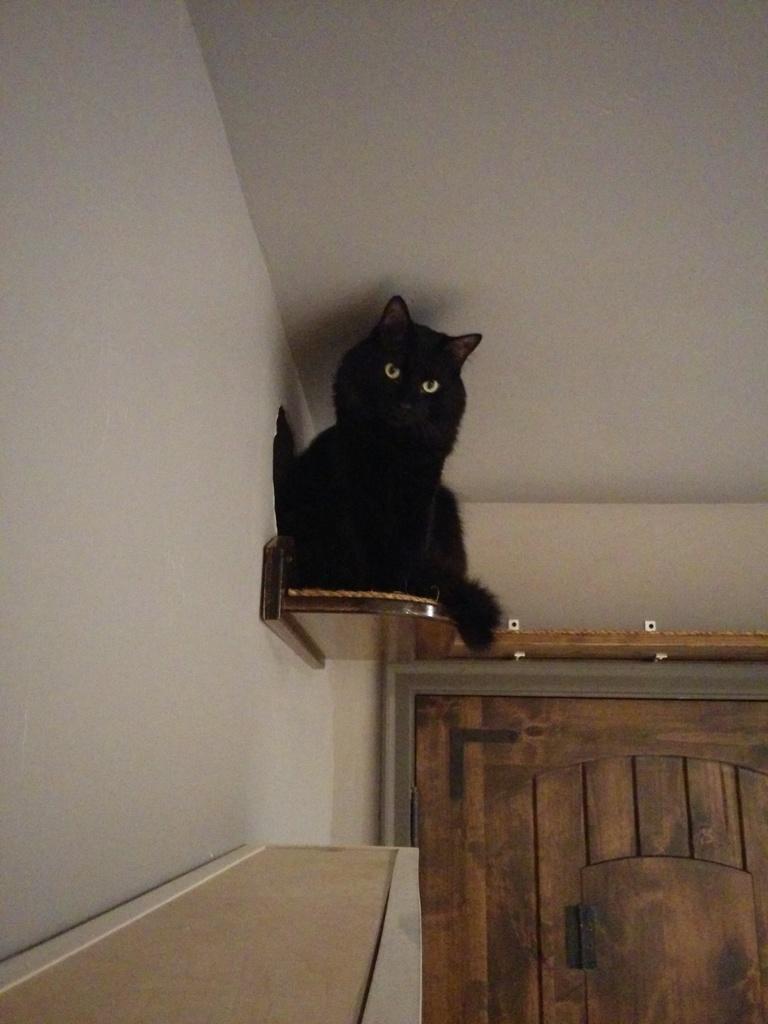How would you summarize this image in a sentence or two? In this image there is a cat sitting on the shelf. In the bottom left there is a shelf. In the bottom right there is a wooden door. At the top there is the ceiling. To the left there is a wall. 